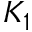<formula> <loc_0><loc_0><loc_500><loc_500>K _ { 1 }</formula> 